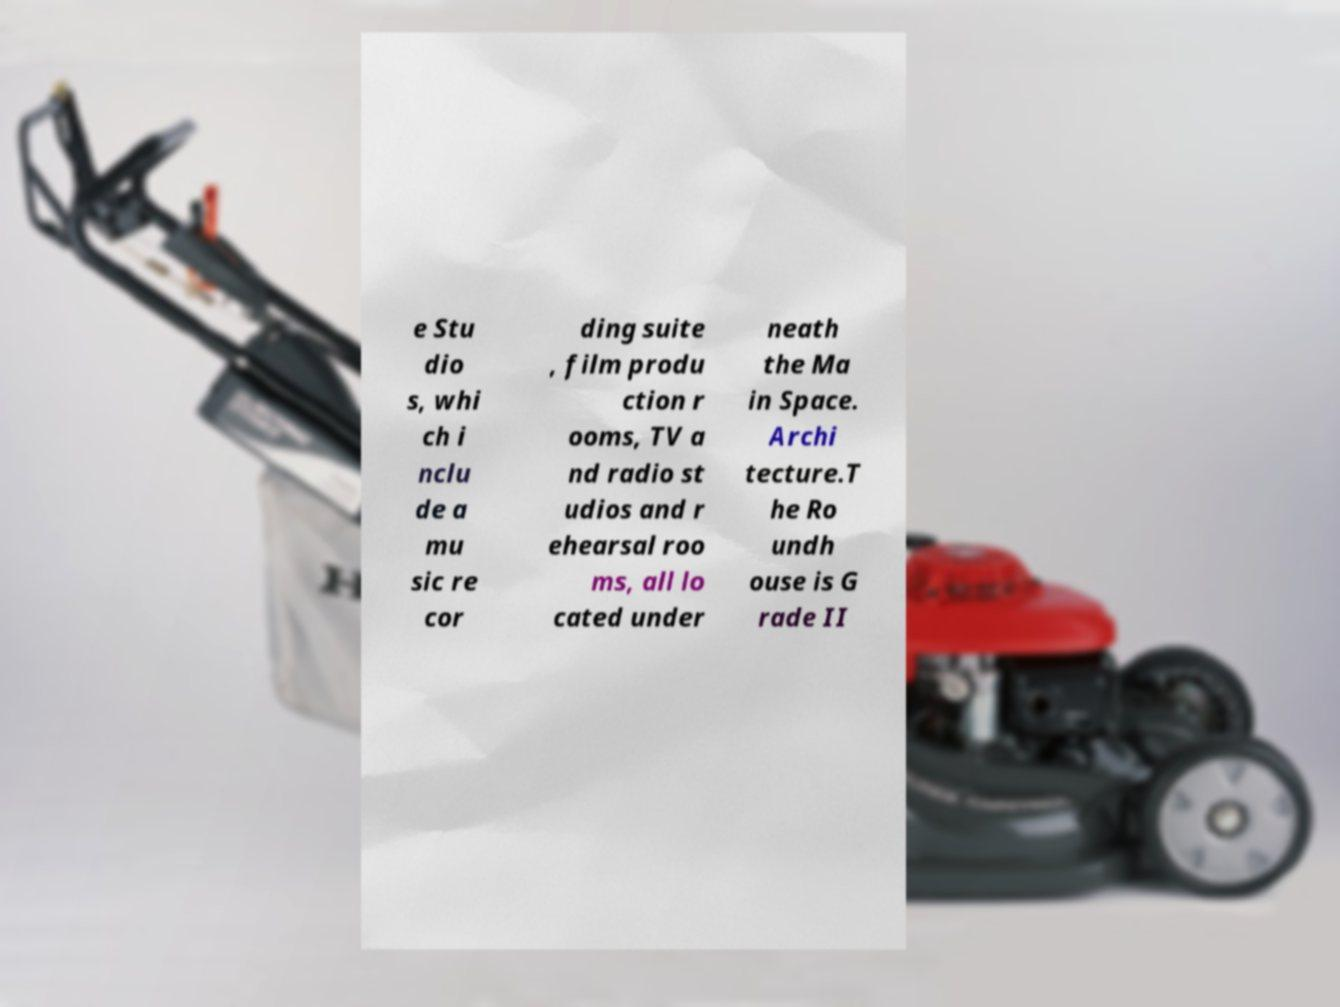What messages or text are displayed in this image? I need them in a readable, typed format. e Stu dio s, whi ch i nclu de a mu sic re cor ding suite , film produ ction r ooms, TV a nd radio st udios and r ehearsal roo ms, all lo cated under neath the Ma in Space. Archi tecture.T he Ro undh ouse is G rade II 